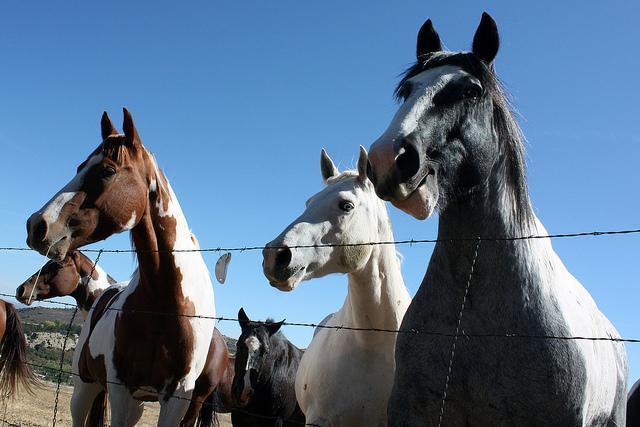How many horses are visible?
Give a very brief answer. 6. How many horses have a white stripe going down their faces?
Give a very brief answer. 2. How many horses are there?
Give a very brief answer. 6. 